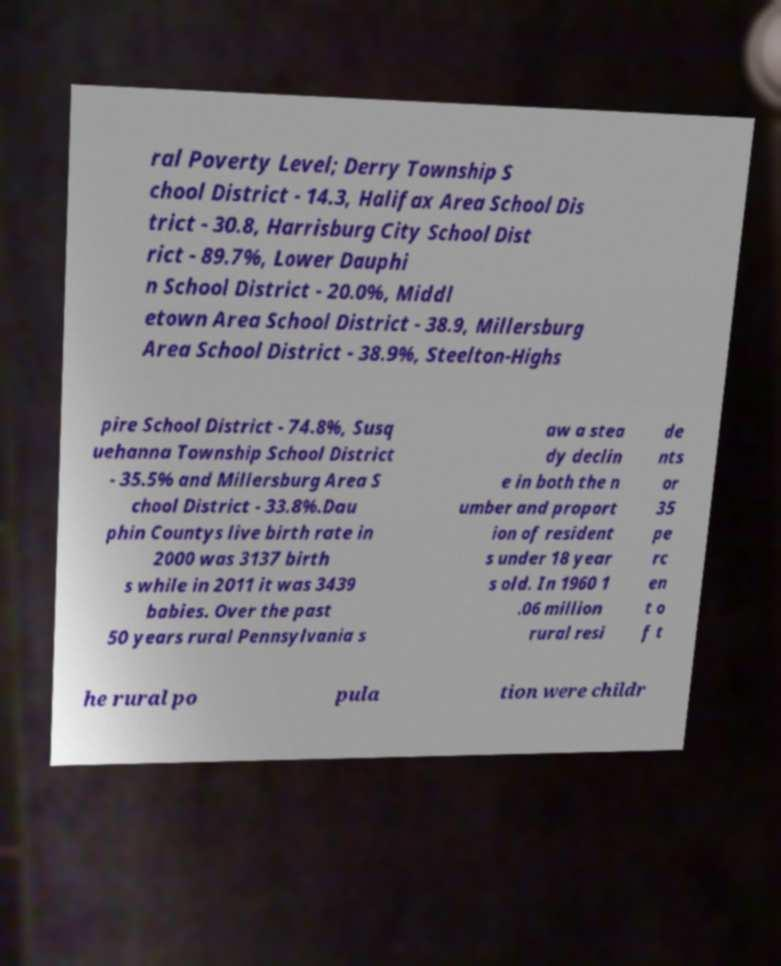Could you extract and type out the text from this image? ral Poverty Level; Derry Township S chool District - 14.3, Halifax Area School Dis trict - 30.8, Harrisburg City School Dist rict - 89.7%, Lower Dauphi n School District - 20.0%, Middl etown Area School District - 38.9, Millersburg Area School District - 38.9%, Steelton-Highs pire School District - 74.8%, Susq uehanna Township School District - 35.5% and Millersburg Area S chool District - 33.8%.Dau phin Countys live birth rate in 2000 was 3137 birth s while in 2011 it was 3439 babies. Over the past 50 years rural Pennsylvania s aw a stea dy declin e in both the n umber and proport ion of resident s under 18 year s old. In 1960 1 .06 million rural resi de nts or 35 pe rc en t o f t he rural po pula tion were childr 